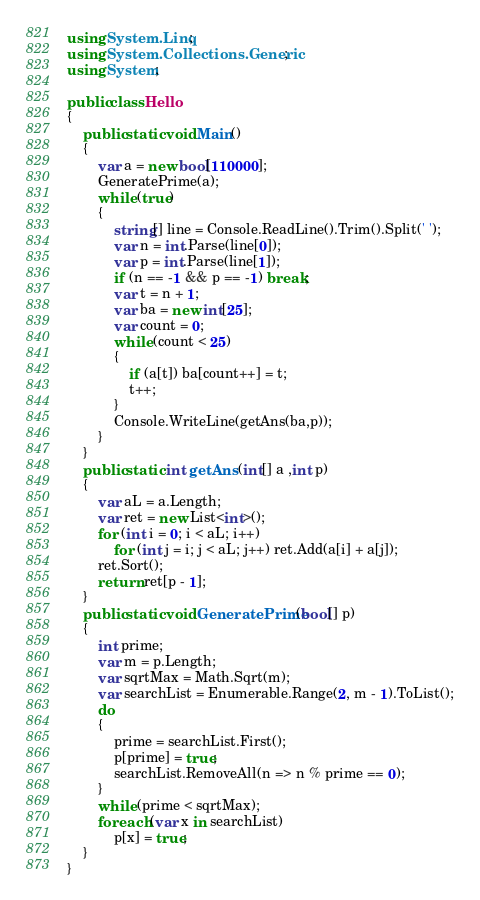Convert code to text. <code><loc_0><loc_0><loc_500><loc_500><_C#_>using System.Linq;
using System.Collections.Generic;
using System;

public class Hello
{
    public static void Main()
    {
        var a = new bool[110000];
        GeneratePrime(a);
        while (true)
        {
            string[] line = Console.ReadLine().Trim().Split(' ');
            var n = int.Parse(line[0]);
            var p = int.Parse(line[1]);
            if (n == -1 && p == -1) break;
            var t = n + 1;
            var ba = new int[25];
            var count = 0;
            while (count < 25)
            {
                if (a[t]) ba[count++] = t;
                t++;
            }
            Console.WriteLine(getAns(ba,p));
        }
    }
    public static int getAns (int[] a ,int p)
    {
        var aL = a.Length;
        var ret = new List<int>();
        for (int i = 0; i < aL; i++)
            for (int j = i; j < aL; j++) ret.Add(a[i] + a[j]);
        ret.Sort();
        return ret[p - 1];
    }
    public static void GeneratePrime(bool[] p)
    {
        int prime;
        var m = p.Length;
        var sqrtMax = Math.Sqrt(m);
        var searchList = Enumerable.Range(2, m - 1).ToList();
        do
        {
            prime = searchList.First();
            p[prime] = true;
            searchList.RemoveAll(n => n % prime == 0);
        }
        while (prime < sqrtMax);
        foreach (var x in searchList)
            p[x] = true;
    }
}

</code> 